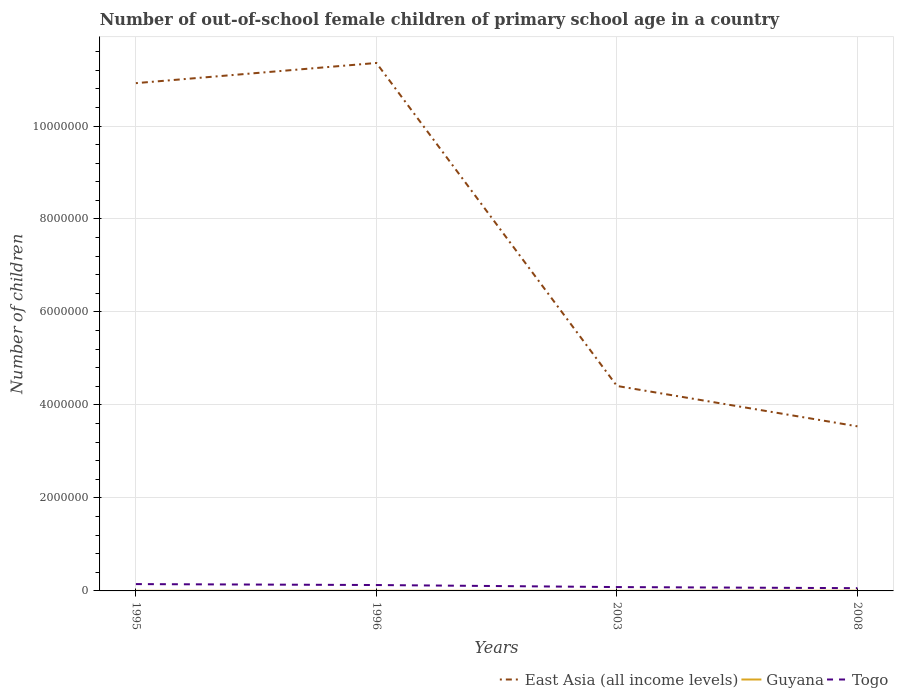Is the number of lines equal to the number of legend labels?
Offer a terse response. Yes. Across all years, what is the maximum number of out-of-school female children in Guyana?
Your answer should be compact. 1311. In which year was the number of out-of-school female children in Guyana maximum?
Offer a terse response. 2003. What is the total number of out-of-school female children in Guyana in the graph?
Offer a very short reply. 972. What is the difference between the highest and the second highest number of out-of-school female children in East Asia (all income levels)?
Provide a short and direct response. 7.82e+06. Is the number of out-of-school female children in East Asia (all income levels) strictly greater than the number of out-of-school female children in Togo over the years?
Keep it short and to the point. No. What is the difference between two consecutive major ticks on the Y-axis?
Make the answer very short. 2.00e+06. Does the graph contain any zero values?
Offer a very short reply. No. Where does the legend appear in the graph?
Keep it short and to the point. Bottom right. How many legend labels are there?
Keep it short and to the point. 3. What is the title of the graph?
Offer a very short reply. Number of out-of-school female children of primary school age in a country. Does "Lesotho" appear as one of the legend labels in the graph?
Keep it short and to the point. No. What is the label or title of the X-axis?
Keep it short and to the point. Years. What is the label or title of the Y-axis?
Provide a short and direct response. Number of children. What is the Number of children of East Asia (all income levels) in 1995?
Provide a succinct answer. 1.09e+07. What is the Number of children in Guyana in 1995?
Offer a very short reply. 1838. What is the Number of children in Togo in 1995?
Provide a short and direct response. 1.47e+05. What is the Number of children in East Asia (all income levels) in 1996?
Provide a succinct answer. 1.14e+07. What is the Number of children in Guyana in 1996?
Offer a very short reply. 2283. What is the Number of children in Togo in 1996?
Your answer should be very brief. 1.27e+05. What is the Number of children of East Asia (all income levels) in 2003?
Your response must be concise. 4.41e+06. What is the Number of children of Guyana in 2003?
Your response must be concise. 1311. What is the Number of children in Togo in 2003?
Offer a terse response. 8.31e+04. What is the Number of children of East Asia (all income levels) in 2008?
Keep it short and to the point. 3.54e+06. What is the Number of children in Guyana in 2008?
Provide a short and direct response. 4096. What is the Number of children in Togo in 2008?
Ensure brevity in your answer.  5.93e+04. Across all years, what is the maximum Number of children of East Asia (all income levels)?
Offer a very short reply. 1.14e+07. Across all years, what is the maximum Number of children in Guyana?
Provide a short and direct response. 4096. Across all years, what is the maximum Number of children of Togo?
Your answer should be very brief. 1.47e+05. Across all years, what is the minimum Number of children in East Asia (all income levels)?
Your answer should be compact. 3.54e+06. Across all years, what is the minimum Number of children in Guyana?
Give a very brief answer. 1311. Across all years, what is the minimum Number of children in Togo?
Offer a very short reply. 5.93e+04. What is the total Number of children in East Asia (all income levels) in the graph?
Your answer should be very brief. 3.02e+07. What is the total Number of children of Guyana in the graph?
Your response must be concise. 9528. What is the total Number of children in Togo in the graph?
Provide a succinct answer. 4.16e+05. What is the difference between the Number of children in East Asia (all income levels) in 1995 and that in 1996?
Provide a short and direct response. -4.34e+05. What is the difference between the Number of children in Guyana in 1995 and that in 1996?
Your answer should be compact. -445. What is the difference between the Number of children of Togo in 1995 and that in 1996?
Your answer should be compact. 2.02e+04. What is the difference between the Number of children of East Asia (all income levels) in 1995 and that in 2003?
Offer a terse response. 6.51e+06. What is the difference between the Number of children in Guyana in 1995 and that in 2003?
Provide a short and direct response. 527. What is the difference between the Number of children in Togo in 1995 and that in 2003?
Your response must be concise. 6.38e+04. What is the difference between the Number of children in East Asia (all income levels) in 1995 and that in 2008?
Provide a short and direct response. 7.38e+06. What is the difference between the Number of children of Guyana in 1995 and that in 2008?
Offer a very short reply. -2258. What is the difference between the Number of children in Togo in 1995 and that in 2008?
Offer a terse response. 8.76e+04. What is the difference between the Number of children in East Asia (all income levels) in 1996 and that in 2003?
Provide a short and direct response. 6.95e+06. What is the difference between the Number of children of Guyana in 1996 and that in 2003?
Provide a short and direct response. 972. What is the difference between the Number of children in Togo in 1996 and that in 2003?
Your response must be concise. 4.36e+04. What is the difference between the Number of children of East Asia (all income levels) in 1996 and that in 2008?
Keep it short and to the point. 7.82e+06. What is the difference between the Number of children of Guyana in 1996 and that in 2008?
Provide a short and direct response. -1813. What is the difference between the Number of children in Togo in 1996 and that in 2008?
Offer a terse response. 6.74e+04. What is the difference between the Number of children of East Asia (all income levels) in 2003 and that in 2008?
Your answer should be very brief. 8.68e+05. What is the difference between the Number of children of Guyana in 2003 and that in 2008?
Offer a very short reply. -2785. What is the difference between the Number of children in Togo in 2003 and that in 2008?
Give a very brief answer. 2.38e+04. What is the difference between the Number of children of East Asia (all income levels) in 1995 and the Number of children of Guyana in 1996?
Make the answer very short. 1.09e+07. What is the difference between the Number of children of East Asia (all income levels) in 1995 and the Number of children of Togo in 1996?
Make the answer very short. 1.08e+07. What is the difference between the Number of children of Guyana in 1995 and the Number of children of Togo in 1996?
Your answer should be very brief. -1.25e+05. What is the difference between the Number of children in East Asia (all income levels) in 1995 and the Number of children in Guyana in 2003?
Offer a very short reply. 1.09e+07. What is the difference between the Number of children in East Asia (all income levels) in 1995 and the Number of children in Togo in 2003?
Your answer should be compact. 1.08e+07. What is the difference between the Number of children of Guyana in 1995 and the Number of children of Togo in 2003?
Provide a succinct answer. -8.12e+04. What is the difference between the Number of children in East Asia (all income levels) in 1995 and the Number of children in Guyana in 2008?
Provide a short and direct response. 1.09e+07. What is the difference between the Number of children of East Asia (all income levels) in 1995 and the Number of children of Togo in 2008?
Your answer should be very brief. 1.09e+07. What is the difference between the Number of children of Guyana in 1995 and the Number of children of Togo in 2008?
Give a very brief answer. -5.75e+04. What is the difference between the Number of children in East Asia (all income levels) in 1996 and the Number of children in Guyana in 2003?
Your response must be concise. 1.14e+07. What is the difference between the Number of children of East Asia (all income levels) in 1996 and the Number of children of Togo in 2003?
Provide a short and direct response. 1.13e+07. What is the difference between the Number of children in Guyana in 1996 and the Number of children in Togo in 2003?
Your response must be concise. -8.08e+04. What is the difference between the Number of children of East Asia (all income levels) in 1996 and the Number of children of Guyana in 2008?
Your answer should be compact. 1.14e+07. What is the difference between the Number of children of East Asia (all income levels) in 1996 and the Number of children of Togo in 2008?
Offer a very short reply. 1.13e+07. What is the difference between the Number of children of Guyana in 1996 and the Number of children of Togo in 2008?
Ensure brevity in your answer.  -5.70e+04. What is the difference between the Number of children of East Asia (all income levels) in 2003 and the Number of children of Guyana in 2008?
Your answer should be compact. 4.40e+06. What is the difference between the Number of children of East Asia (all income levels) in 2003 and the Number of children of Togo in 2008?
Your answer should be very brief. 4.35e+06. What is the difference between the Number of children in Guyana in 2003 and the Number of children in Togo in 2008?
Give a very brief answer. -5.80e+04. What is the average Number of children in East Asia (all income levels) per year?
Offer a very short reply. 7.56e+06. What is the average Number of children of Guyana per year?
Provide a succinct answer. 2382. What is the average Number of children of Togo per year?
Provide a short and direct response. 1.04e+05. In the year 1995, what is the difference between the Number of children in East Asia (all income levels) and Number of children in Guyana?
Provide a short and direct response. 1.09e+07. In the year 1995, what is the difference between the Number of children in East Asia (all income levels) and Number of children in Togo?
Your answer should be very brief. 1.08e+07. In the year 1995, what is the difference between the Number of children of Guyana and Number of children of Togo?
Keep it short and to the point. -1.45e+05. In the year 1996, what is the difference between the Number of children in East Asia (all income levels) and Number of children in Guyana?
Offer a very short reply. 1.14e+07. In the year 1996, what is the difference between the Number of children of East Asia (all income levels) and Number of children of Togo?
Provide a succinct answer. 1.12e+07. In the year 1996, what is the difference between the Number of children in Guyana and Number of children in Togo?
Give a very brief answer. -1.24e+05. In the year 2003, what is the difference between the Number of children in East Asia (all income levels) and Number of children in Guyana?
Provide a short and direct response. 4.41e+06. In the year 2003, what is the difference between the Number of children in East Asia (all income levels) and Number of children in Togo?
Your answer should be very brief. 4.33e+06. In the year 2003, what is the difference between the Number of children in Guyana and Number of children in Togo?
Your response must be concise. -8.18e+04. In the year 2008, what is the difference between the Number of children in East Asia (all income levels) and Number of children in Guyana?
Give a very brief answer. 3.54e+06. In the year 2008, what is the difference between the Number of children of East Asia (all income levels) and Number of children of Togo?
Give a very brief answer. 3.48e+06. In the year 2008, what is the difference between the Number of children of Guyana and Number of children of Togo?
Keep it short and to the point. -5.52e+04. What is the ratio of the Number of children of East Asia (all income levels) in 1995 to that in 1996?
Your answer should be compact. 0.96. What is the ratio of the Number of children of Guyana in 1995 to that in 1996?
Keep it short and to the point. 0.81. What is the ratio of the Number of children of Togo in 1995 to that in 1996?
Your response must be concise. 1.16. What is the ratio of the Number of children in East Asia (all income levels) in 1995 to that in 2003?
Give a very brief answer. 2.48. What is the ratio of the Number of children of Guyana in 1995 to that in 2003?
Keep it short and to the point. 1.4. What is the ratio of the Number of children of Togo in 1995 to that in 2003?
Ensure brevity in your answer.  1.77. What is the ratio of the Number of children in East Asia (all income levels) in 1995 to that in 2008?
Provide a succinct answer. 3.09. What is the ratio of the Number of children in Guyana in 1995 to that in 2008?
Keep it short and to the point. 0.45. What is the ratio of the Number of children of Togo in 1995 to that in 2008?
Your response must be concise. 2.48. What is the ratio of the Number of children in East Asia (all income levels) in 1996 to that in 2003?
Offer a very short reply. 2.58. What is the ratio of the Number of children of Guyana in 1996 to that in 2003?
Offer a terse response. 1.74. What is the ratio of the Number of children in Togo in 1996 to that in 2003?
Provide a short and direct response. 1.53. What is the ratio of the Number of children of East Asia (all income levels) in 1996 to that in 2008?
Provide a succinct answer. 3.21. What is the ratio of the Number of children of Guyana in 1996 to that in 2008?
Your response must be concise. 0.56. What is the ratio of the Number of children of Togo in 1996 to that in 2008?
Give a very brief answer. 2.14. What is the ratio of the Number of children of East Asia (all income levels) in 2003 to that in 2008?
Make the answer very short. 1.25. What is the ratio of the Number of children in Guyana in 2003 to that in 2008?
Make the answer very short. 0.32. What is the ratio of the Number of children in Togo in 2003 to that in 2008?
Make the answer very short. 1.4. What is the difference between the highest and the second highest Number of children of East Asia (all income levels)?
Provide a short and direct response. 4.34e+05. What is the difference between the highest and the second highest Number of children in Guyana?
Give a very brief answer. 1813. What is the difference between the highest and the second highest Number of children of Togo?
Your answer should be compact. 2.02e+04. What is the difference between the highest and the lowest Number of children in East Asia (all income levels)?
Provide a succinct answer. 7.82e+06. What is the difference between the highest and the lowest Number of children of Guyana?
Give a very brief answer. 2785. What is the difference between the highest and the lowest Number of children of Togo?
Provide a short and direct response. 8.76e+04. 